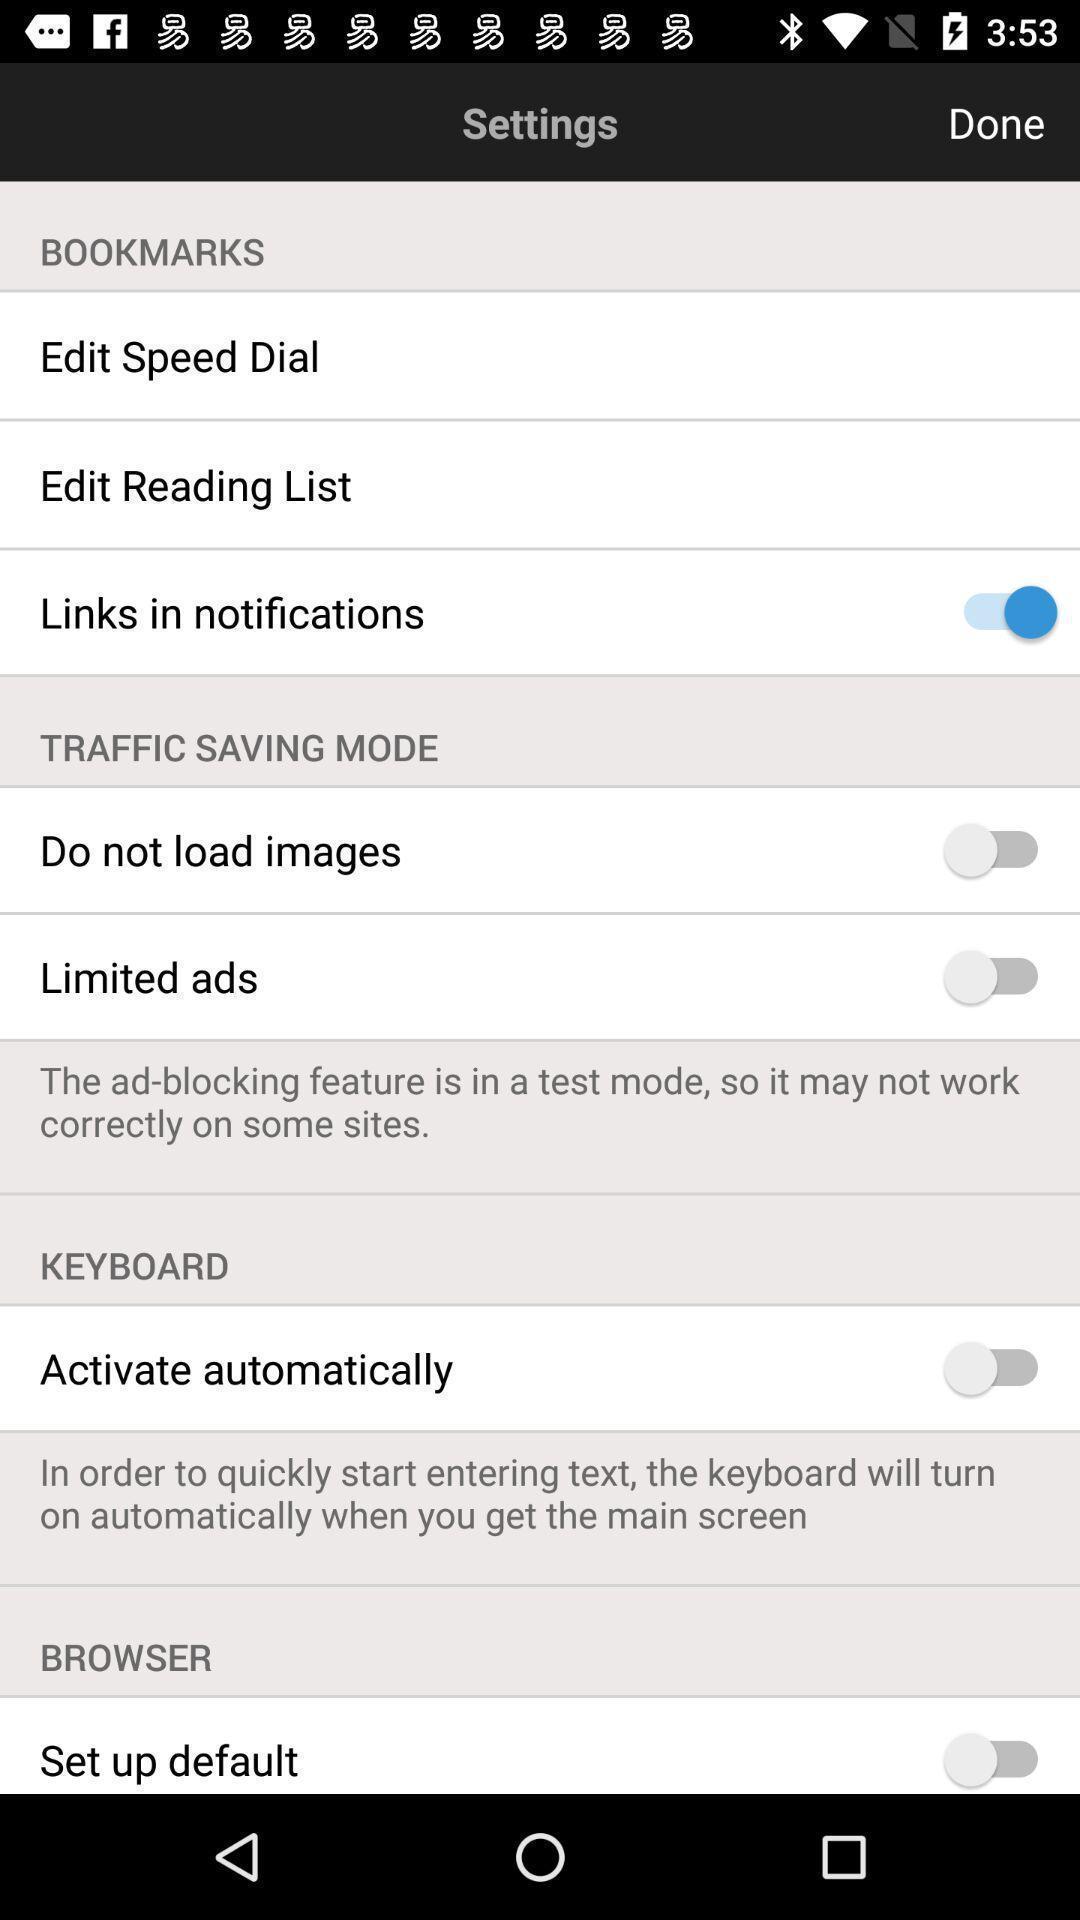Tell me what you see in this picture. Screen showing settings page. 